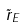Convert formula to latex. <formula><loc_0><loc_0><loc_500><loc_500>\tilde { r } _ { E }</formula> 